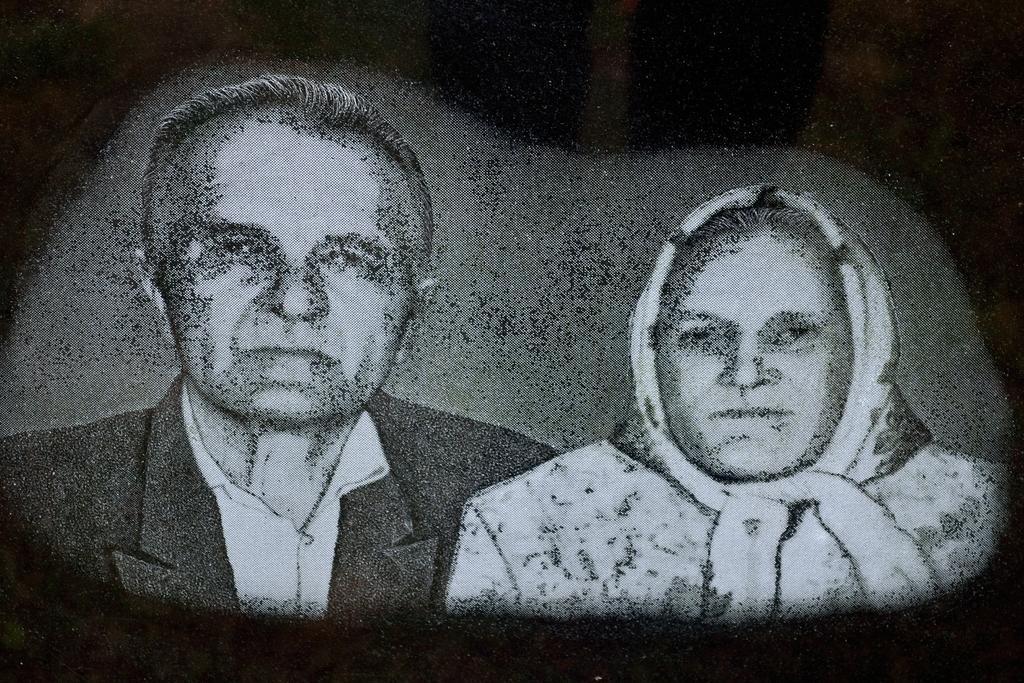In one or two sentences, can you explain what this image depicts? In this picture I can see there is a man and a woman picture and the man is wearing a black blazer and they are smiling. 